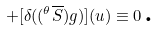Convert formula to latex. <formula><loc_0><loc_0><loc_500><loc_500>+ [ \delta ( ( ^ { \theta } \overline { S } ) g ) ] ( u ) \equiv 0 \, \text {.}</formula> 